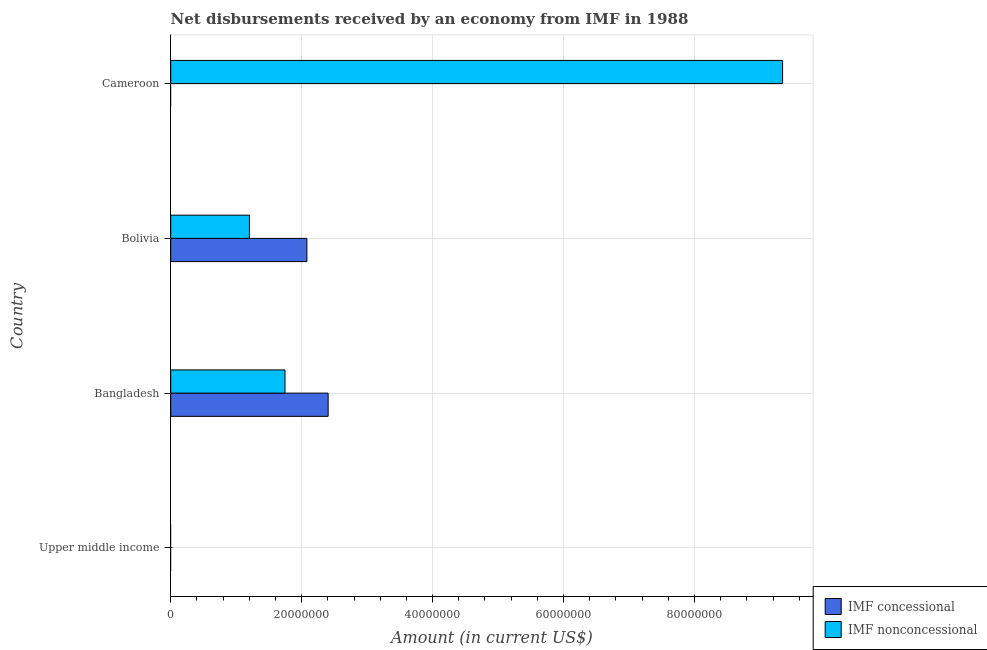How many bars are there on the 1st tick from the top?
Provide a short and direct response. 1. How many bars are there on the 3rd tick from the bottom?
Provide a short and direct response. 2. What is the net non concessional disbursements from imf in Cameroon?
Keep it short and to the point. 9.35e+07. Across all countries, what is the maximum net concessional disbursements from imf?
Offer a terse response. 2.40e+07. What is the total net concessional disbursements from imf in the graph?
Offer a very short reply. 4.48e+07. What is the difference between the net non concessional disbursements from imf in Bolivia and that in Cameroon?
Make the answer very short. -8.14e+07. What is the difference between the net non concessional disbursements from imf in Bangladesh and the net concessional disbursements from imf in Upper middle income?
Offer a very short reply. 1.75e+07. What is the average net non concessional disbursements from imf per country?
Give a very brief answer. 3.07e+07. What is the difference between the net non concessional disbursements from imf and net concessional disbursements from imf in Bangladesh?
Give a very brief answer. -6.59e+06. What is the ratio of the net concessional disbursements from imf in Bangladesh to that in Bolivia?
Provide a succinct answer. 1.16. Is the net non concessional disbursements from imf in Bolivia less than that in Cameroon?
Keep it short and to the point. Yes. What is the difference between the highest and the second highest net non concessional disbursements from imf?
Your answer should be compact. 7.60e+07. What is the difference between the highest and the lowest net concessional disbursements from imf?
Give a very brief answer. 2.40e+07. Are all the bars in the graph horizontal?
Provide a short and direct response. Yes. What is the difference between two consecutive major ticks on the X-axis?
Your response must be concise. 2.00e+07. Are the values on the major ticks of X-axis written in scientific E-notation?
Keep it short and to the point. No. Does the graph contain any zero values?
Your answer should be compact. Yes. How are the legend labels stacked?
Make the answer very short. Vertical. What is the title of the graph?
Offer a terse response. Net disbursements received by an economy from IMF in 1988. What is the Amount (in current US$) of IMF concessional in Bangladesh?
Your response must be concise. 2.40e+07. What is the Amount (in current US$) of IMF nonconcessional in Bangladesh?
Provide a succinct answer. 1.75e+07. What is the Amount (in current US$) in IMF concessional in Bolivia?
Give a very brief answer. 2.08e+07. What is the Amount (in current US$) in IMF nonconcessional in Bolivia?
Provide a succinct answer. 1.20e+07. What is the Amount (in current US$) in IMF concessional in Cameroon?
Make the answer very short. 0. What is the Amount (in current US$) of IMF nonconcessional in Cameroon?
Offer a terse response. 9.35e+07. Across all countries, what is the maximum Amount (in current US$) of IMF concessional?
Keep it short and to the point. 2.40e+07. Across all countries, what is the maximum Amount (in current US$) in IMF nonconcessional?
Your answer should be compact. 9.35e+07. Across all countries, what is the minimum Amount (in current US$) in IMF concessional?
Your answer should be compact. 0. What is the total Amount (in current US$) in IMF concessional in the graph?
Your answer should be very brief. 4.48e+07. What is the total Amount (in current US$) of IMF nonconcessional in the graph?
Your response must be concise. 1.23e+08. What is the difference between the Amount (in current US$) of IMF concessional in Bangladesh and that in Bolivia?
Provide a short and direct response. 3.25e+06. What is the difference between the Amount (in current US$) of IMF nonconcessional in Bangladesh and that in Bolivia?
Provide a short and direct response. 5.44e+06. What is the difference between the Amount (in current US$) of IMF nonconcessional in Bangladesh and that in Cameroon?
Keep it short and to the point. -7.60e+07. What is the difference between the Amount (in current US$) of IMF nonconcessional in Bolivia and that in Cameroon?
Provide a succinct answer. -8.14e+07. What is the difference between the Amount (in current US$) of IMF concessional in Bangladesh and the Amount (in current US$) of IMF nonconcessional in Bolivia?
Make the answer very short. 1.20e+07. What is the difference between the Amount (in current US$) of IMF concessional in Bangladesh and the Amount (in current US$) of IMF nonconcessional in Cameroon?
Ensure brevity in your answer.  -6.94e+07. What is the difference between the Amount (in current US$) in IMF concessional in Bolivia and the Amount (in current US$) in IMF nonconcessional in Cameroon?
Make the answer very short. -7.27e+07. What is the average Amount (in current US$) of IMF concessional per country?
Make the answer very short. 1.12e+07. What is the average Amount (in current US$) in IMF nonconcessional per country?
Make the answer very short. 3.07e+07. What is the difference between the Amount (in current US$) in IMF concessional and Amount (in current US$) in IMF nonconcessional in Bangladesh?
Provide a short and direct response. 6.59e+06. What is the difference between the Amount (in current US$) of IMF concessional and Amount (in current US$) of IMF nonconcessional in Bolivia?
Offer a very short reply. 8.78e+06. What is the ratio of the Amount (in current US$) of IMF concessional in Bangladesh to that in Bolivia?
Provide a short and direct response. 1.16. What is the ratio of the Amount (in current US$) of IMF nonconcessional in Bangladesh to that in Bolivia?
Provide a succinct answer. 1.45. What is the ratio of the Amount (in current US$) in IMF nonconcessional in Bangladesh to that in Cameroon?
Offer a very short reply. 0.19. What is the ratio of the Amount (in current US$) of IMF nonconcessional in Bolivia to that in Cameroon?
Your answer should be compact. 0.13. What is the difference between the highest and the second highest Amount (in current US$) in IMF nonconcessional?
Keep it short and to the point. 7.60e+07. What is the difference between the highest and the lowest Amount (in current US$) in IMF concessional?
Provide a short and direct response. 2.40e+07. What is the difference between the highest and the lowest Amount (in current US$) of IMF nonconcessional?
Ensure brevity in your answer.  9.35e+07. 